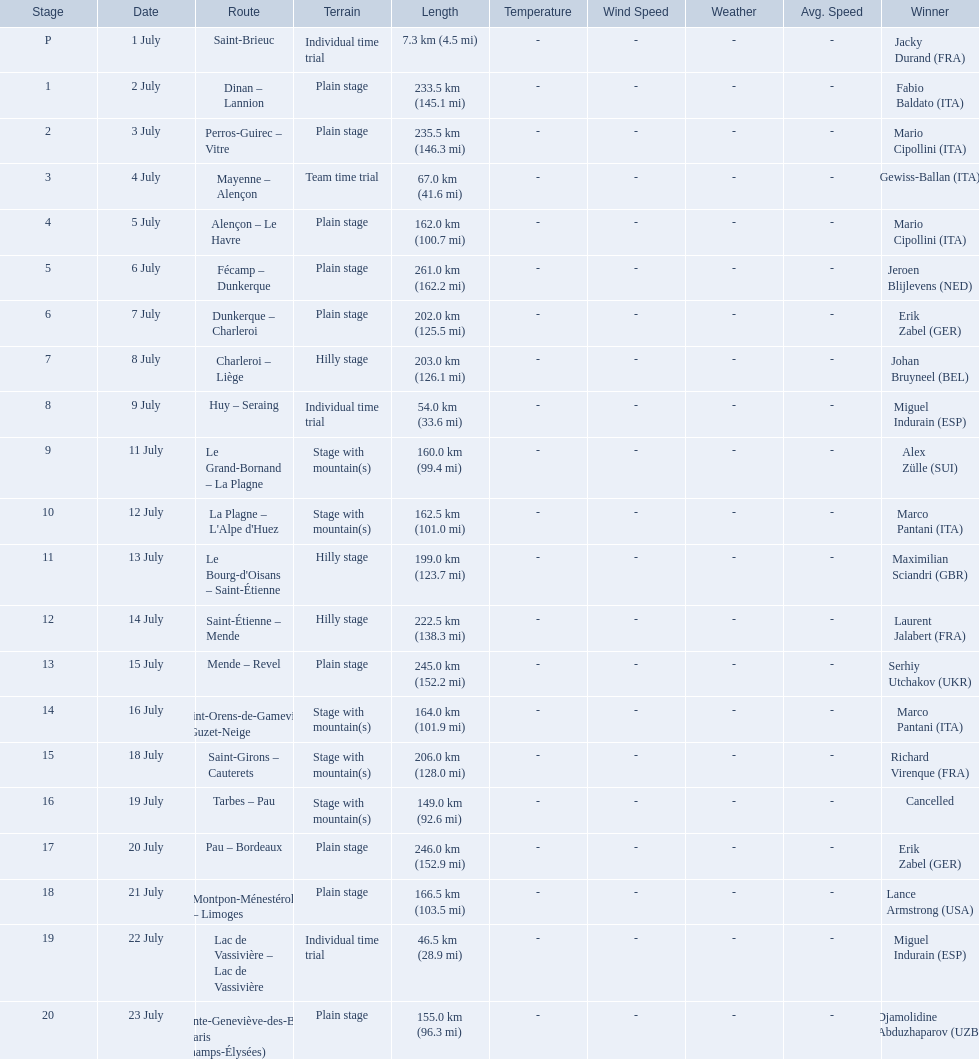What were the lengths of all the stages of the 1995 tour de france? 7.3 km (4.5 mi), 233.5 km (145.1 mi), 235.5 km (146.3 mi), 67.0 km (41.6 mi), 162.0 km (100.7 mi), 261.0 km (162.2 mi), 202.0 km (125.5 mi), 203.0 km (126.1 mi), 54.0 km (33.6 mi), 160.0 km (99.4 mi), 162.5 km (101.0 mi), 199.0 km (123.7 mi), 222.5 km (138.3 mi), 245.0 km (152.2 mi), 164.0 km (101.9 mi), 206.0 km (128.0 mi), 149.0 km (92.6 mi), 246.0 km (152.9 mi), 166.5 km (103.5 mi), 46.5 km (28.9 mi), 155.0 km (96.3 mi). Of those, which one occurred on july 8th? 203.0 km (126.1 mi). 